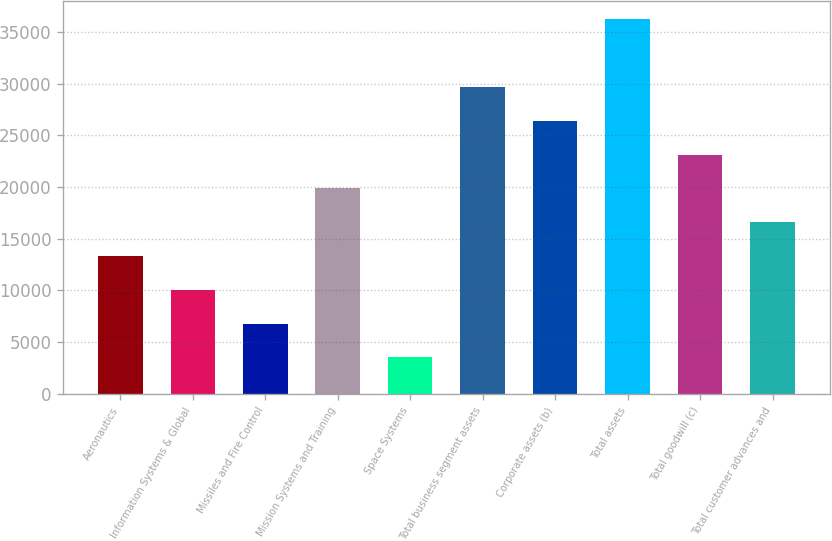Convert chart to OTSL. <chart><loc_0><loc_0><loc_500><loc_500><bar_chart><fcel>Aeronautics<fcel>Information Systems & Global<fcel>Missiles and Fire Control<fcel>Mission Systems and Training<fcel>Space Systems<fcel>Total business segment assets<fcel>Corporate assets (b)<fcel>Total assets<fcel>Total goodwill (c)<fcel>Total customer advances and<nl><fcel>13321.8<fcel>10055.2<fcel>6788.6<fcel>19855<fcel>3522<fcel>29654.8<fcel>26388.2<fcel>36188<fcel>23121.6<fcel>16588.4<nl></chart> 